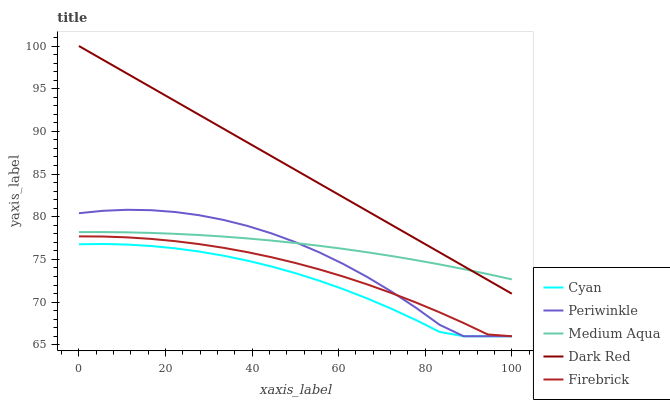Does Firebrick have the minimum area under the curve?
Answer yes or no. No. Does Firebrick have the maximum area under the curve?
Answer yes or no. No. Is Cyan the smoothest?
Answer yes or no. No. Is Cyan the roughest?
Answer yes or no. No. Does Dark Red have the lowest value?
Answer yes or no. No. Does Firebrick have the highest value?
Answer yes or no. No. Is Firebrick less than Dark Red?
Answer yes or no. Yes. Is Dark Red greater than Cyan?
Answer yes or no. Yes. Does Firebrick intersect Dark Red?
Answer yes or no. No. 